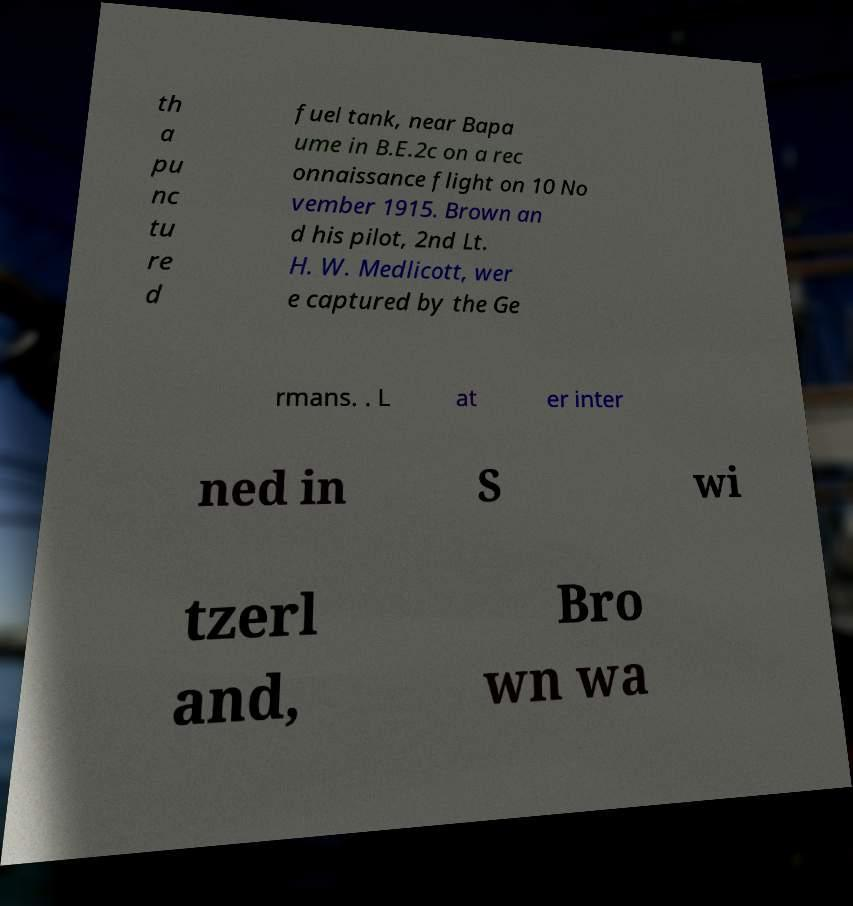Can you accurately transcribe the text from the provided image for me? th a pu nc tu re d fuel tank, near Bapa ume in B.E.2c on a rec onnaissance flight on 10 No vember 1915. Brown an d his pilot, 2nd Lt. H. W. Medlicott, wer e captured by the Ge rmans. . L at er inter ned in S wi tzerl and, Bro wn wa 